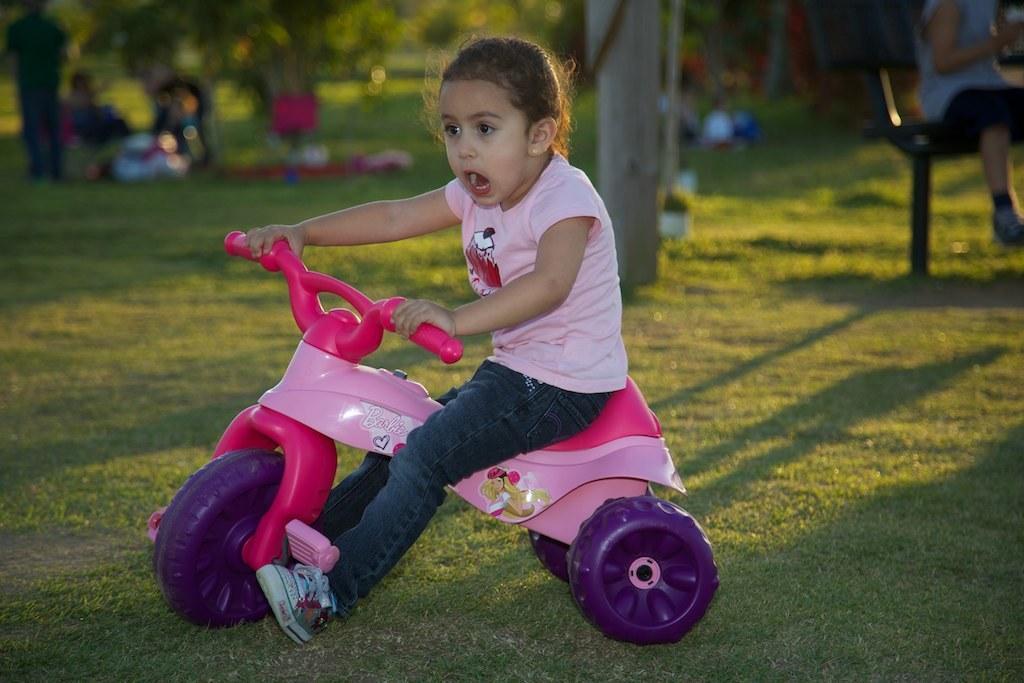Describe this image in one or two sentences. In this image I can see the person sitting on the toy bicycle which is in pink and purple color. And the person is wearing the pink and blue color dress. In the back I can see the few more people and also many trees. 